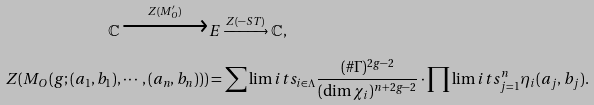<formula> <loc_0><loc_0><loc_500><loc_500>\mathbb { C } \xrightarrow [ ] { Z ( M _ { O } ^ { \prime } ) } & E \xrightarrow [ ] { Z ( - S T ) } \mathbb { C } , \\ Z ( M _ { O } ( g ; ( a _ { 1 } , b _ { 1 } ) , \cdots , ( a _ { n } , b _ { n } ) ) ) & = \sum \lim i t s _ { i \in \Lambda } \frac { ( \# \Gamma ) ^ { 2 g - 2 } } { ( \dim \chi _ { i } ) ^ { n + 2 g - 2 } } \cdot \prod \lim i t s _ { j = 1 } ^ { n } \eta _ { i } ( a _ { j } , b _ { j } ) .</formula> 